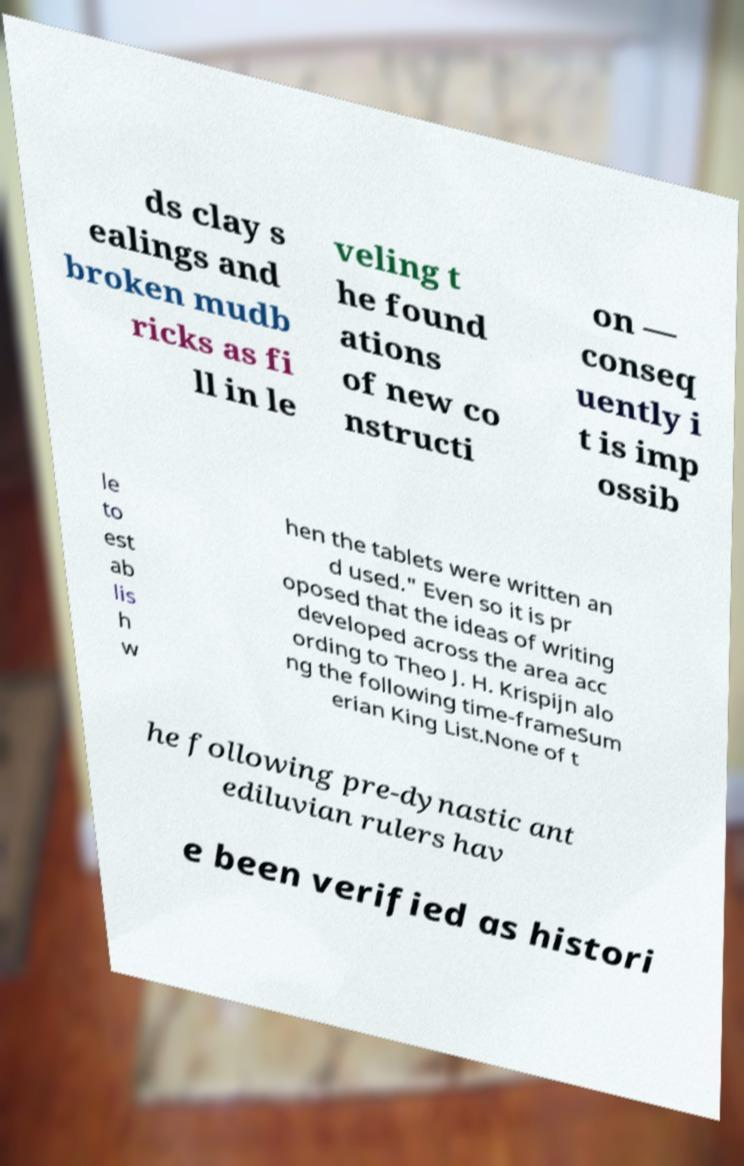Please identify and transcribe the text found in this image. ds clay s ealings and broken mudb ricks as fi ll in le veling t he found ations of new co nstructi on — conseq uently i t is imp ossib le to est ab lis h w hen the tablets were written an d used." Even so it is pr oposed that the ideas of writing developed across the area acc ording to Theo J. H. Krispijn alo ng the following time-frameSum erian King List.None of t he following pre-dynastic ant ediluvian rulers hav e been verified as histori 